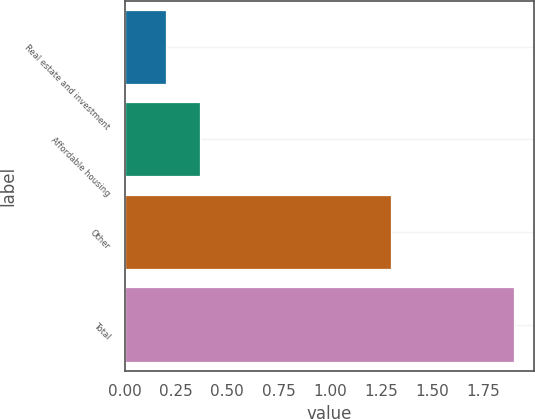Convert chart. <chart><loc_0><loc_0><loc_500><loc_500><bar_chart><fcel>Real estate and investment<fcel>Affordable housing<fcel>Other<fcel>Total<nl><fcel>0.2<fcel>0.37<fcel>1.3<fcel>1.9<nl></chart> 